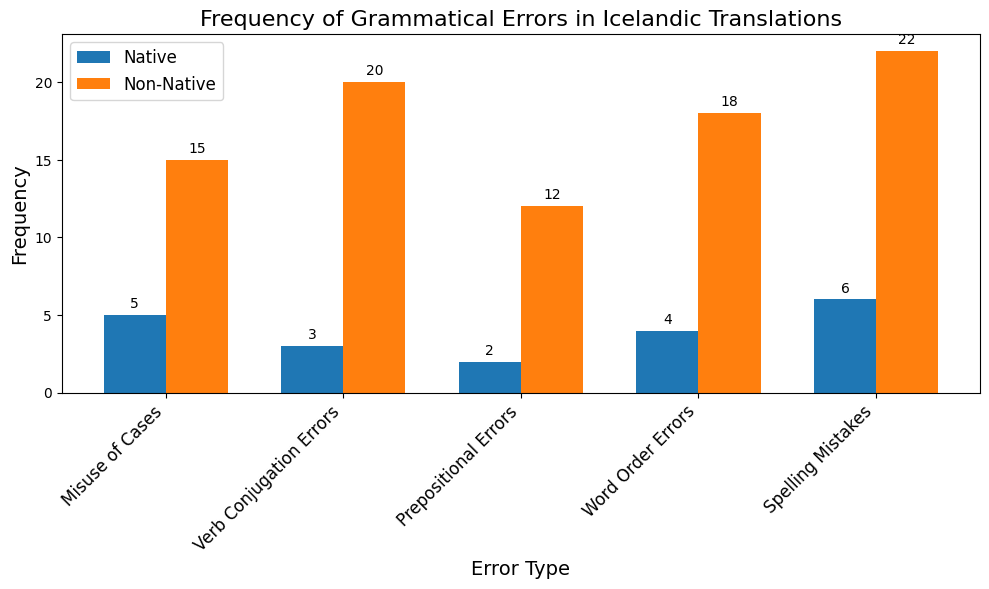What is the most common error type among non-native translators? Looking at the heights of the orange bars representing non-native translators, the bar for "Spelling Mistakes" is the tallest, indicating the highest frequency.
Answer: Spelling Mistakes How many more spelling mistakes do non-native translators make compared to native translators? The frequency of spelling mistakes for native translators is 6, while for non-native translators it is 22. The difference is calculated as 22 - 6 = 16.
Answer: 16 Which error type do native translators make least frequently? By examining the heights of the blue bars for native translators, the "Prepositional Errors" bar is the shortest, indicating the lowest frequency.
Answer: Prepositional Errors What is the total frequency of verb conjugation errors made by both native and non-native translators combined? The frequency for native translators is 3, and for non-native translators it is 20. Summing these values gives 3 + 20 = 23.
Answer: 23 Which group makes more errors overall, and by how much? Summing the error frequencies for native translators (5 + 3 + 2 + 4 + 6 = 20) and non-native translators (15 + 20 + 12 + 18 + 22 = 87), non-native translators make more errors. The difference is 87 - 20 = 67.
Answer: Non-Native, by 67 Are there any error types where native translators make more errors than non-native translators? By comparing the heights of the blue and orange bars for each error type, we see that no blue bar (native translator) is taller than the corresponding orange bar (non-native translator).
Answer: No What percentage of misuse of cases errors are made by native translators out of the total misuse of cases errors? The total misuse of cases errors is 5 (native) + 15 (non-native) = 20. The percentage is (5 / 20) * 100 = 25%.
Answer: 25% In which error type is the difference in the number of errors between native and non-native translators the largest? Calculating the difference for each error type: Misuse of Cases (15 - 5 = 10), Verb Conjugation Errors (20 - 3 = 17), Prepositional Errors (12 - 2 = 10), Word Order Errors (18 - 4 = 14), Spelling Mistakes (22 - 6 = 16). The largest difference is found in Verb Conjugation Errors with a difference of 17.
Answer: Verb Conjugation Errors How many total errors are made in word order by both groups combined? The frequencies for word order errors are 4 (native) and 18 (non-native). The total is 4 + 18 = 22.
Answer: 22 